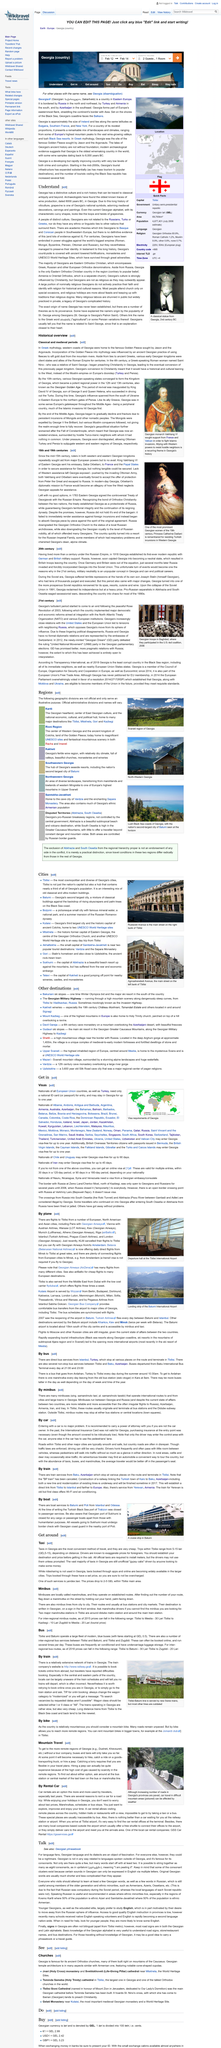Indicate a few pertinent items in this graphic. UNESCO World Heritage sites are located in the Georgian cities of Kutaisi and Mtskheta. The above picture portrays the Tbilisi-Batumi railway line, which is a crucial transportation route connecting the capital city of Tbilisi with the coastal city of Batumi. The line represents the resilience and determination of the Georgian people to rebuild and modernize their infrastructure in the face of adversity. The capital of Georgia is Tbilisi, which is a fact that is widely known and accepted. The picture was taken in 2006. Nationals of Iran can remain in Georgia for up to 45 days without a visa, according to the declaration. 